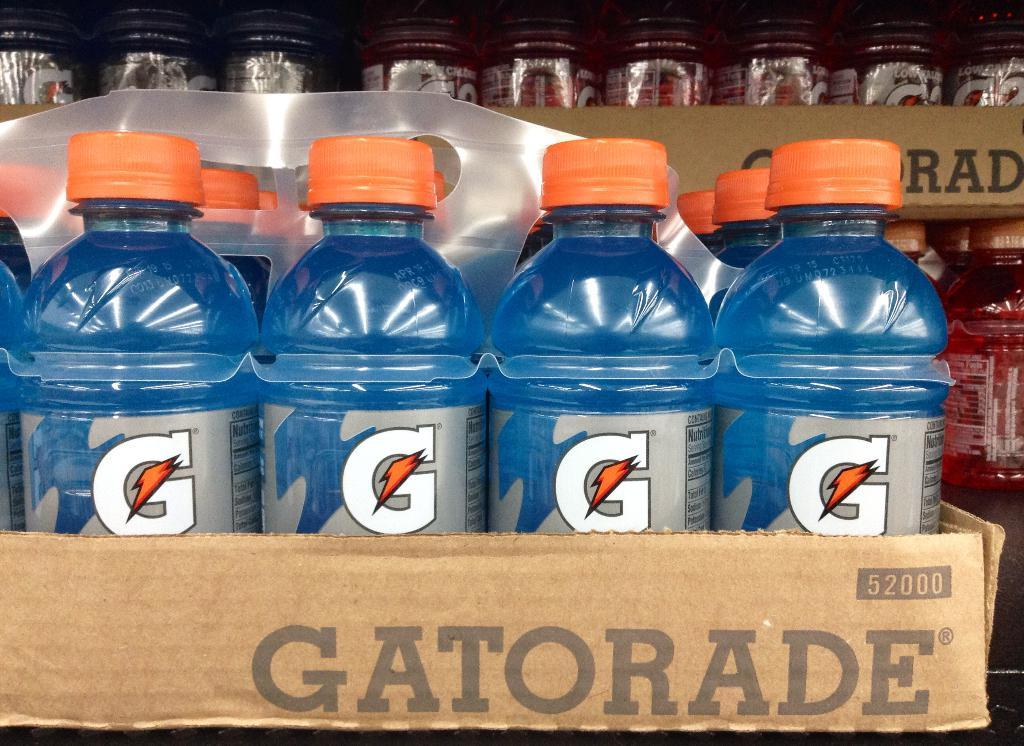<image>
Write a terse but informative summary of the picture. case of blue quart size gatorade number 52000 in front of red bottles 